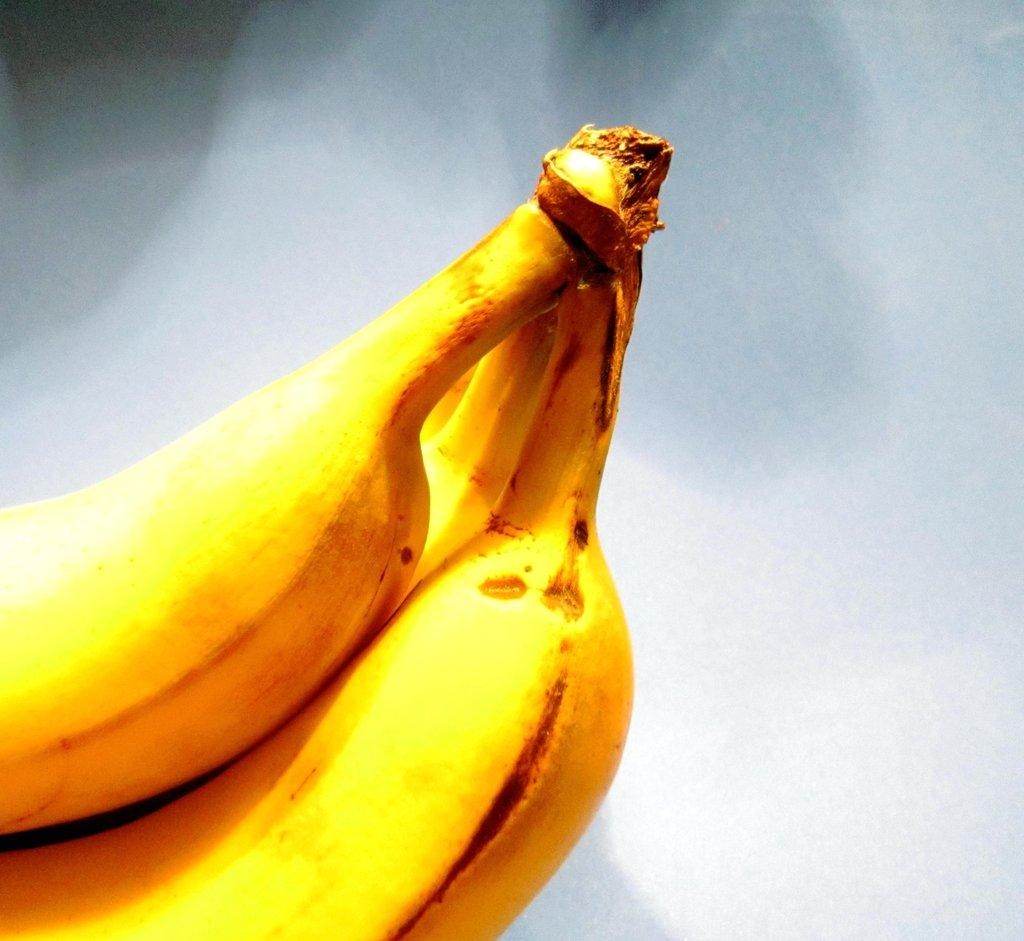What is on the floor in the image? There are bananas on the floor in the image. What type of umbrella is being used by the bear in the industry depicted in the image? There is no umbrella, bear, or industry present in the image; it only features bananas on the floor. 